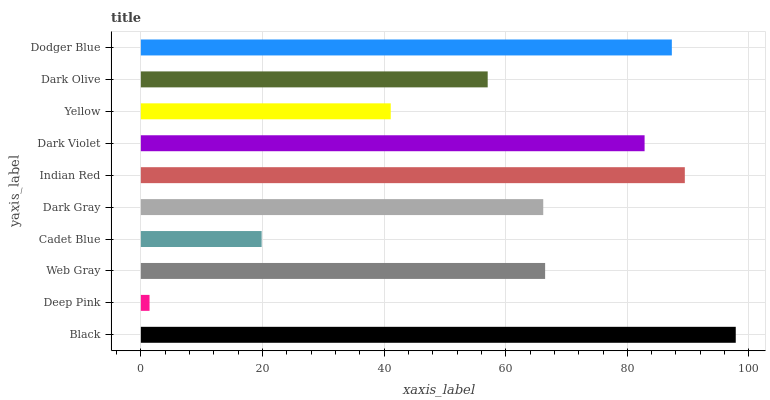Is Deep Pink the minimum?
Answer yes or no. Yes. Is Black the maximum?
Answer yes or no. Yes. Is Web Gray the minimum?
Answer yes or no. No. Is Web Gray the maximum?
Answer yes or no. No. Is Web Gray greater than Deep Pink?
Answer yes or no. Yes. Is Deep Pink less than Web Gray?
Answer yes or no. Yes. Is Deep Pink greater than Web Gray?
Answer yes or no. No. Is Web Gray less than Deep Pink?
Answer yes or no. No. Is Web Gray the high median?
Answer yes or no. Yes. Is Dark Gray the low median?
Answer yes or no. Yes. Is Yellow the high median?
Answer yes or no. No. Is Cadet Blue the low median?
Answer yes or no. No. 